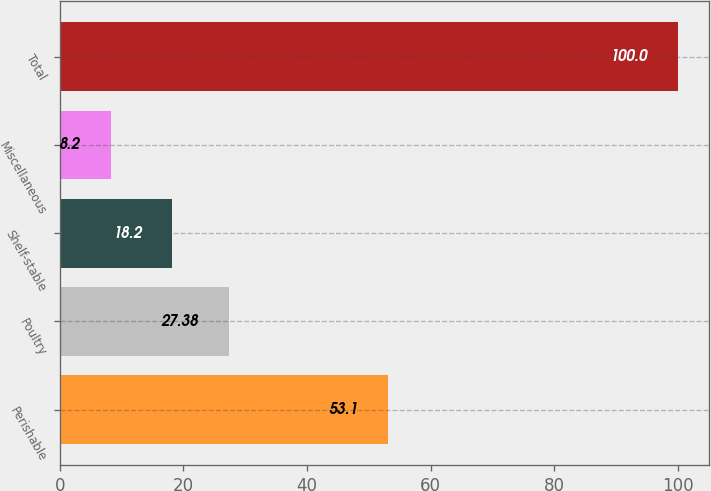Convert chart. <chart><loc_0><loc_0><loc_500><loc_500><bar_chart><fcel>Perishable<fcel>Poultry<fcel>Shelf-stable<fcel>Miscellaneous<fcel>Total<nl><fcel>53.1<fcel>27.38<fcel>18.2<fcel>8.2<fcel>100<nl></chart> 